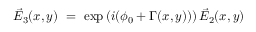<formula> <loc_0><loc_0><loc_500><loc_500>\vec { E } _ { 3 } ( x , y ) = \exp \left ( i ( \phi _ { 0 } + \Gamma ( x , y ) ) \right ) \vec { E } _ { 2 } ( x , y )</formula> 